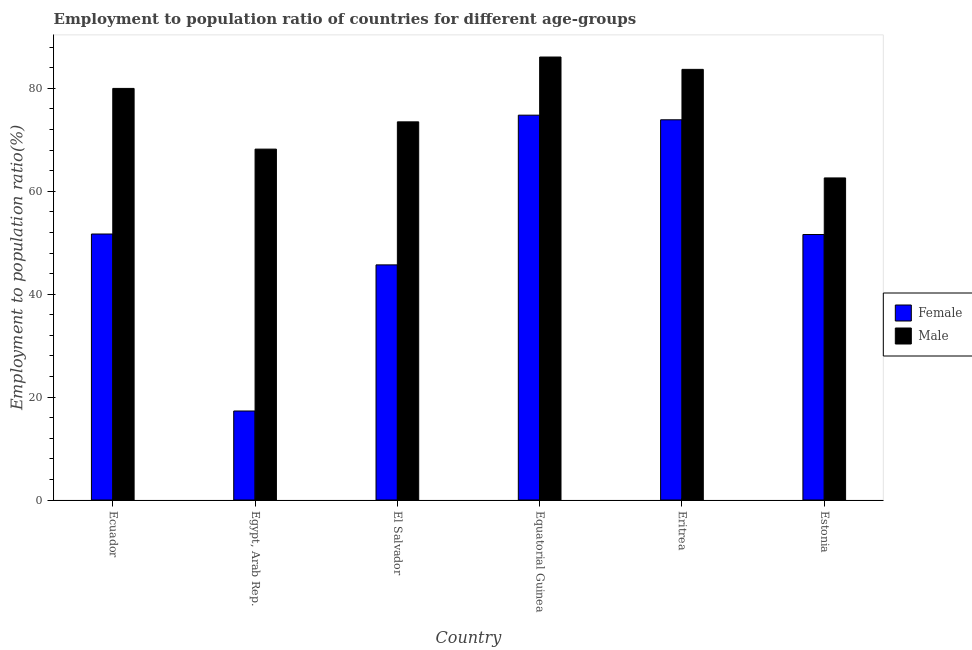How many different coloured bars are there?
Ensure brevity in your answer.  2. How many groups of bars are there?
Your answer should be compact. 6. Are the number of bars per tick equal to the number of legend labels?
Keep it short and to the point. Yes. How many bars are there on the 4th tick from the left?
Give a very brief answer. 2. How many bars are there on the 4th tick from the right?
Keep it short and to the point. 2. What is the label of the 5th group of bars from the left?
Make the answer very short. Eritrea. In how many cases, is the number of bars for a given country not equal to the number of legend labels?
Your response must be concise. 0. What is the employment to population ratio(female) in Ecuador?
Offer a terse response. 51.7. Across all countries, what is the maximum employment to population ratio(female)?
Make the answer very short. 74.8. Across all countries, what is the minimum employment to population ratio(male)?
Your response must be concise. 62.6. In which country was the employment to population ratio(female) maximum?
Give a very brief answer. Equatorial Guinea. In which country was the employment to population ratio(female) minimum?
Keep it short and to the point. Egypt, Arab Rep. What is the total employment to population ratio(female) in the graph?
Provide a short and direct response. 315. What is the difference between the employment to population ratio(female) in El Salvador and that in Estonia?
Give a very brief answer. -5.9. What is the difference between the employment to population ratio(male) in Ecuador and the employment to population ratio(female) in El Salvador?
Your answer should be very brief. 34.3. What is the average employment to population ratio(male) per country?
Make the answer very short. 75.68. What is the difference between the employment to population ratio(male) and employment to population ratio(female) in El Salvador?
Give a very brief answer. 27.8. What is the ratio of the employment to population ratio(male) in Eritrea to that in Estonia?
Provide a short and direct response. 1.34. What is the difference between the highest and the second highest employment to population ratio(female)?
Keep it short and to the point. 0.9. What is the difference between the highest and the lowest employment to population ratio(female)?
Your answer should be very brief. 57.5. Is the sum of the employment to population ratio(male) in Ecuador and Eritrea greater than the maximum employment to population ratio(female) across all countries?
Your answer should be very brief. Yes. What does the 1st bar from the right in El Salvador represents?
Your answer should be very brief. Male. Are all the bars in the graph horizontal?
Your answer should be very brief. No. Are the values on the major ticks of Y-axis written in scientific E-notation?
Give a very brief answer. No. Does the graph contain grids?
Keep it short and to the point. No. Where does the legend appear in the graph?
Your answer should be compact. Center right. How are the legend labels stacked?
Offer a very short reply. Vertical. What is the title of the graph?
Offer a very short reply. Employment to population ratio of countries for different age-groups. Does "Public credit registry" appear as one of the legend labels in the graph?
Offer a very short reply. No. What is the Employment to population ratio(%) of Female in Ecuador?
Give a very brief answer. 51.7. What is the Employment to population ratio(%) in Female in Egypt, Arab Rep.?
Your response must be concise. 17.3. What is the Employment to population ratio(%) of Male in Egypt, Arab Rep.?
Make the answer very short. 68.2. What is the Employment to population ratio(%) of Female in El Salvador?
Your answer should be very brief. 45.7. What is the Employment to population ratio(%) in Male in El Salvador?
Your answer should be very brief. 73.5. What is the Employment to population ratio(%) of Female in Equatorial Guinea?
Give a very brief answer. 74.8. What is the Employment to population ratio(%) in Male in Equatorial Guinea?
Offer a terse response. 86.1. What is the Employment to population ratio(%) in Female in Eritrea?
Make the answer very short. 73.9. What is the Employment to population ratio(%) in Male in Eritrea?
Make the answer very short. 83.7. What is the Employment to population ratio(%) in Female in Estonia?
Your response must be concise. 51.6. What is the Employment to population ratio(%) of Male in Estonia?
Ensure brevity in your answer.  62.6. Across all countries, what is the maximum Employment to population ratio(%) in Female?
Provide a succinct answer. 74.8. Across all countries, what is the maximum Employment to population ratio(%) in Male?
Your answer should be very brief. 86.1. Across all countries, what is the minimum Employment to population ratio(%) of Female?
Your answer should be very brief. 17.3. Across all countries, what is the minimum Employment to population ratio(%) in Male?
Provide a succinct answer. 62.6. What is the total Employment to population ratio(%) of Female in the graph?
Your response must be concise. 315. What is the total Employment to population ratio(%) of Male in the graph?
Your response must be concise. 454.1. What is the difference between the Employment to population ratio(%) of Female in Ecuador and that in Egypt, Arab Rep.?
Ensure brevity in your answer.  34.4. What is the difference between the Employment to population ratio(%) in Male in Ecuador and that in Egypt, Arab Rep.?
Give a very brief answer. 11.8. What is the difference between the Employment to population ratio(%) in Female in Ecuador and that in Equatorial Guinea?
Your answer should be very brief. -23.1. What is the difference between the Employment to population ratio(%) of Female in Ecuador and that in Eritrea?
Your response must be concise. -22.2. What is the difference between the Employment to population ratio(%) of Male in Ecuador and that in Estonia?
Your answer should be compact. 17.4. What is the difference between the Employment to population ratio(%) in Female in Egypt, Arab Rep. and that in El Salvador?
Offer a very short reply. -28.4. What is the difference between the Employment to population ratio(%) of Female in Egypt, Arab Rep. and that in Equatorial Guinea?
Provide a succinct answer. -57.5. What is the difference between the Employment to population ratio(%) in Male in Egypt, Arab Rep. and that in Equatorial Guinea?
Provide a short and direct response. -17.9. What is the difference between the Employment to population ratio(%) of Female in Egypt, Arab Rep. and that in Eritrea?
Offer a terse response. -56.6. What is the difference between the Employment to population ratio(%) of Male in Egypt, Arab Rep. and that in Eritrea?
Your answer should be compact. -15.5. What is the difference between the Employment to population ratio(%) in Female in Egypt, Arab Rep. and that in Estonia?
Keep it short and to the point. -34.3. What is the difference between the Employment to population ratio(%) in Male in Egypt, Arab Rep. and that in Estonia?
Your answer should be compact. 5.6. What is the difference between the Employment to population ratio(%) in Female in El Salvador and that in Equatorial Guinea?
Offer a terse response. -29.1. What is the difference between the Employment to population ratio(%) in Male in El Salvador and that in Equatorial Guinea?
Keep it short and to the point. -12.6. What is the difference between the Employment to population ratio(%) in Female in El Salvador and that in Eritrea?
Your answer should be very brief. -28.2. What is the difference between the Employment to population ratio(%) in Male in El Salvador and that in Estonia?
Ensure brevity in your answer.  10.9. What is the difference between the Employment to population ratio(%) of Male in Equatorial Guinea and that in Eritrea?
Your response must be concise. 2.4. What is the difference between the Employment to population ratio(%) in Female in Equatorial Guinea and that in Estonia?
Your response must be concise. 23.2. What is the difference between the Employment to population ratio(%) in Female in Eritrea and that in Estonia?
Provide a short and direct response. 22.3. What is the difference between the Employment to population ratio(%) in Male in Eritrea and that in Estonia?
Make the answer very short. 21.1. What is the difference between the Employment to population ratio(%) in Female in Ecuador and the Employment to population ratio(%) in Male in Egypt, Arab Rep.?
Keep it short and to the point. -16.5. What is the difference between the Employment to population ratio(%) in Female in Ecuador and the Employment to population ratio(%) in Male in El Salvador?
Your answer should be very brief. -21.8. What is the difference between the Employment to population ratio(%) of Female in Ecuador and the Employment to population ratio(%) of Male in Equatorial Guinea?
Your answer should be compact. -34.4. What is the difference between the Employment to population ratio(%) of Female in Ecuador and the Employment to population ratio(%) of Male in Eritrea?
Offer a terse response. -32. What is the difference between the Employment to population ratio(%) of Female in Ecuador and the Employment to population ratio(%) of Male in Estonia?
Provide a succinct answer. -10.9. What is the difference between the Employment to population ratio(%) in Female in Egypt, Arab Rep. and the Employment to population ratio(%) in Male in El Salvador?
Give a very brief answer. -56.2. What is the difference between the Employment to population ratio(%) in Female in Egypt, Arab Rep. and the Employment to population ratio(%) in Male in Equatorial Guinea?
Provide a short and direct response. -68.8. What is the difference between the Employment to population ratio(%) in Female in Egypt, Arab Rep. and the Employment to population ratio(%) in Male in Eritrea?
Provide a succinct answer. -66.4. What is the difference between the Employment to population ratio(%) of Female in Egypt, Arab Rep. and the Employment to population ratio(%) of Male in Estonia?
Keep it short and to the point. -45.3. What is the difference between the Employment to population ratio(%) of Female in El Salvador and the Employment to population ratio(%) of Male in Equatorial Guinea?
Make the answer very short. -40.4. What is the difference between the Employment to population ratio(%) in Female in El Salvador and the Employment to population ratio(%) in Male in Eritrea?
Ensure brevity in your answer.  -38. What is the difference between the Employment to population ratio(%) of Female in El Salvador and the Employment to population ratio(%) of Male in Estonia?
Offer a terse response. -16.9. What is the difference between the Employment to population ratio(%) in Female in Equatorial Guinea and the Employment to population ratio(%) in Male in Eritrea?
Make the answer very short. -8.9. What is the difference between the Employment to population ratio(%) of Female in Eritrea and the Employment to population ratio(%) of Male in Estonia?
Your answer should be very brief. 11.3. What is the average Employment to population ratio(%) in Female per country?
Provide a succinct answer. 52.5. What is the average Employment to population ratio(%) in Male per country?
Provide a succinct answer. 75.68. What is the difference between the Employment to population ratio(%) in Female and Employment to population ratio(%) in Male in Ecuador?
Provide a short and direct response. -28.3. What is the difference between the Employment to population ratio(%) of Female and Employment to population ratio(%) of Male in Egypt, Arab Rep.?
Make the answer very short. -50.9. What is the difference between the Employment to population ratio(%) in Female and Employment to population ratio(%) in Male in El Salvador?
Your answer should be compact. -27.8. What is the difference between the Employment to population ratio(%) in Female and Employment to population ratio(%) in Male in Eritrea?
Keep it short and to the point. -9.8. What is the difference between the Employment to population ratio(%) of Female and Employment to population ratio(%) of Male in Estonia?
Your answer should be very brief. -11. What is the ratio of the Employment to population ratio(%) in Female in Ecuador to that in Egypt, Arab Rep.?
Provide a short and direct response. 2.99. What is the ratio of the Employment to population ratio(%) in Male in Ecuador to that in Egypt, Arab Rep.?
Give a very brief answer. 1.17. What is the ratio of the Employment to population ratio(%) of Female in Ecuador to that in El Salvador?
Make the answer very short. 1.13. What is the ratio of the Employment to population ratio(%) in Male in Ecuador to that in El Salvador?
Make the answer very short. 1.09. What is the ratio of the Employment to population ratio(%) in Female in Ecuador to that in Equatorial Guinea?
Keep it short and to the point. 0.69. What is the ratio of the Employment to population ratio(%) of Male in Ecuador to that in Equatorial Guinea?
Offer a terse response. 0.93. What is the ratio of the Employment to population ratio(%) of Female in Ecuador to that in Eritrea?
Keep it short and to the point. 0.7. What is the ratio of the Employment to population ratio(%) in Male in Ecuador to that in Eritrea?
Offer a very short reply. 0.96. What is the ratio of the Employment to population ratio(%) in Female in Ecuador to that in Estonia?
Provide a succinct answer. 1. What is the ratio of the Employment to population ratio(%) in Male in Ecuador to that in Estonia?
Your answer should be compact. 1.28. What is the ratio of the Employment to population ratio(%) of Female in Egypt, Arab Rep. to that in El Salvador?
Your answer should be compact. 0.38. What is the ratio of the Employment to population ratio(%) in Male in Egypt, Arab Rep. to that in El Salvador?
Ensure brevity in your answer.  0.93. What is the ratio of the Employment to population ratio(%) in Female in Egypt, Arab Rep. to that in Equatorial Guinea?
Offer a terse response. 0.23. What is the ratio of the Employment to population ratio(%) of Male in Egypt, Arab Rep. to that in Equatorial Guinea?
Offer a terse response. 0.79. What is the ratio of the Employment to population ratio(%) in Female in Egypt, Arab Rep. to that in Eritrea?
Offer a very short reply. 0.23. What is the ratio of the Employment to population ratio(%) of Male in Egypt, Arab Rep. to that in Eritrea?
Provide a succinct answer. 0.81. What is the ratio of the Employment to population ratio(%) of Female in Egypt, Arab Rep. to that in Estonia?
Ensure brevity in your answer.  0.34. What is the ratio of the Employment to population ratio(%) of Male in Egypt, Arab Rep. to that in Estonia?
Offer a very short reply. 1.09. What is the ratio of the Employment to population ratio(%) in Female in El Salvador to that in Equatorial Guinea?
Ensure brevity in your answer.  0.61. What is the ratio of the Employment to population ratio(%) of Male in El Salvador to that in Equatorial Guinea?
Your answer should be compact. 0.85. What is the ratio of the Employment to population ratio(%) of Female in El Salvador to that in Eritrea?
Offer a terse response. 0.62. What is the ratio of the Employment to population ratio(%) of Male in El Salvador to that in Eritrea?
Ensure brevity in your answer.  0.88. What is the ratio of the Employment to population ratio(%) of Female in El Salvador to that in Estonia?
Offer a terse response. 0.89. What is the ratio of the Employment to population ratio(%) of Male in El Salvador to that in Estonia?
Give a very brief answer. 1.17. What is the ratio of the Employment to population ratio(%) of Female in Equatorial Guinea to that in Eritrea?
Your answer should be very brief. 1.01. What is the ratio of the Employment to population ratio(%) of Male in Equatorial Guinea to that in Eritrea?
Provide a short and direct response. 1.03. What is the ratio of the Employment to population ratio(%) of Female in Equatorial Guinea to that in Estonia?
Your answer should be compact. 1.45. What is the ratio of the Employment to population ratio(%) of Male in Equatorial Guinea to that in Estonia?
Your answer should be very brief. 1.38. What is the ratio of the Employment to population ratio(%) in Female in Eritrea to that in Estonia?
Provide a short and direct response. 1.43. What is the ratio of the Employment to population ratio(%) of Male in Eritrea to that in Estonia?
Your response must be concise. 1.34. What is the difference between the highest and the second highest Employment to population ratio(%) of Female?
Your answer should be very brief. 0.9. What is the difference between the highest and the lowest Employment to population ratio(%) in Female?
Give a very brief answer. 57.5. 